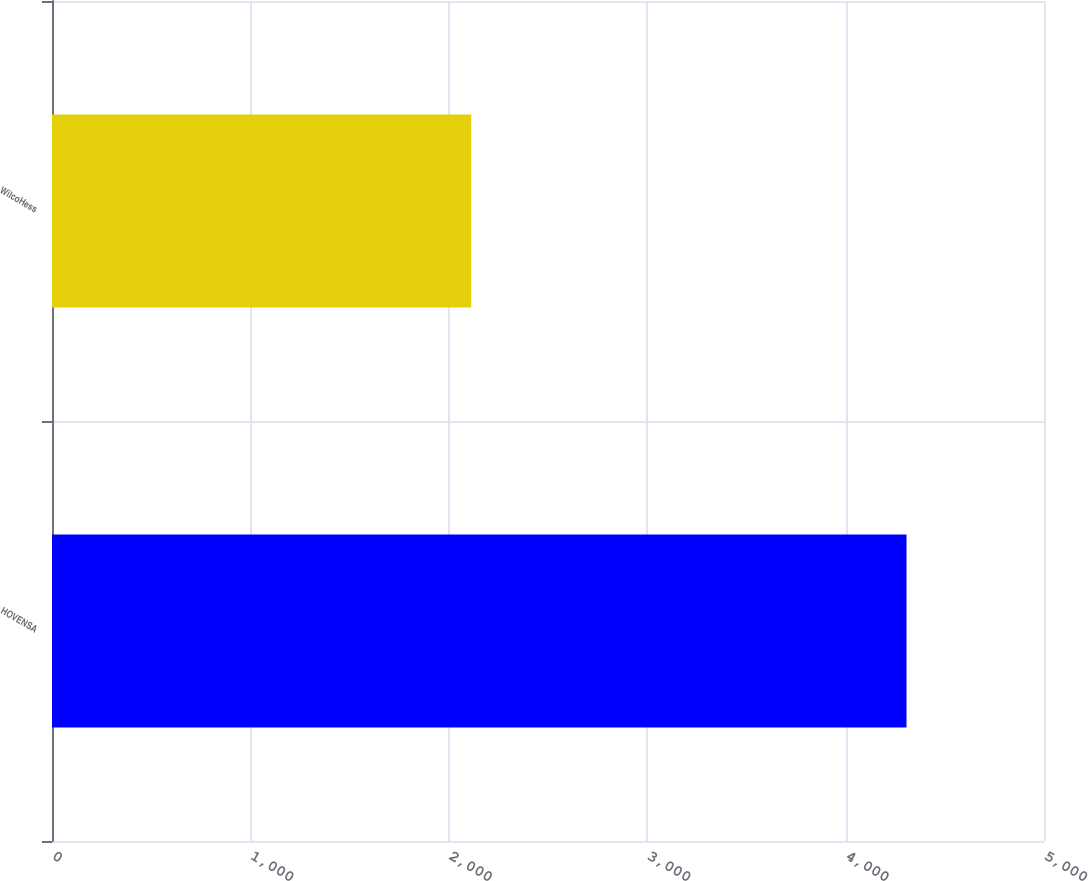Convert chart. <chart><loc_0><loc_0><loc_500><loc_500><bar_chart><fcel>HOVENSA<fcel>WilcoHess<nl><fcel>4307<fcel>2113<nl></chart> 